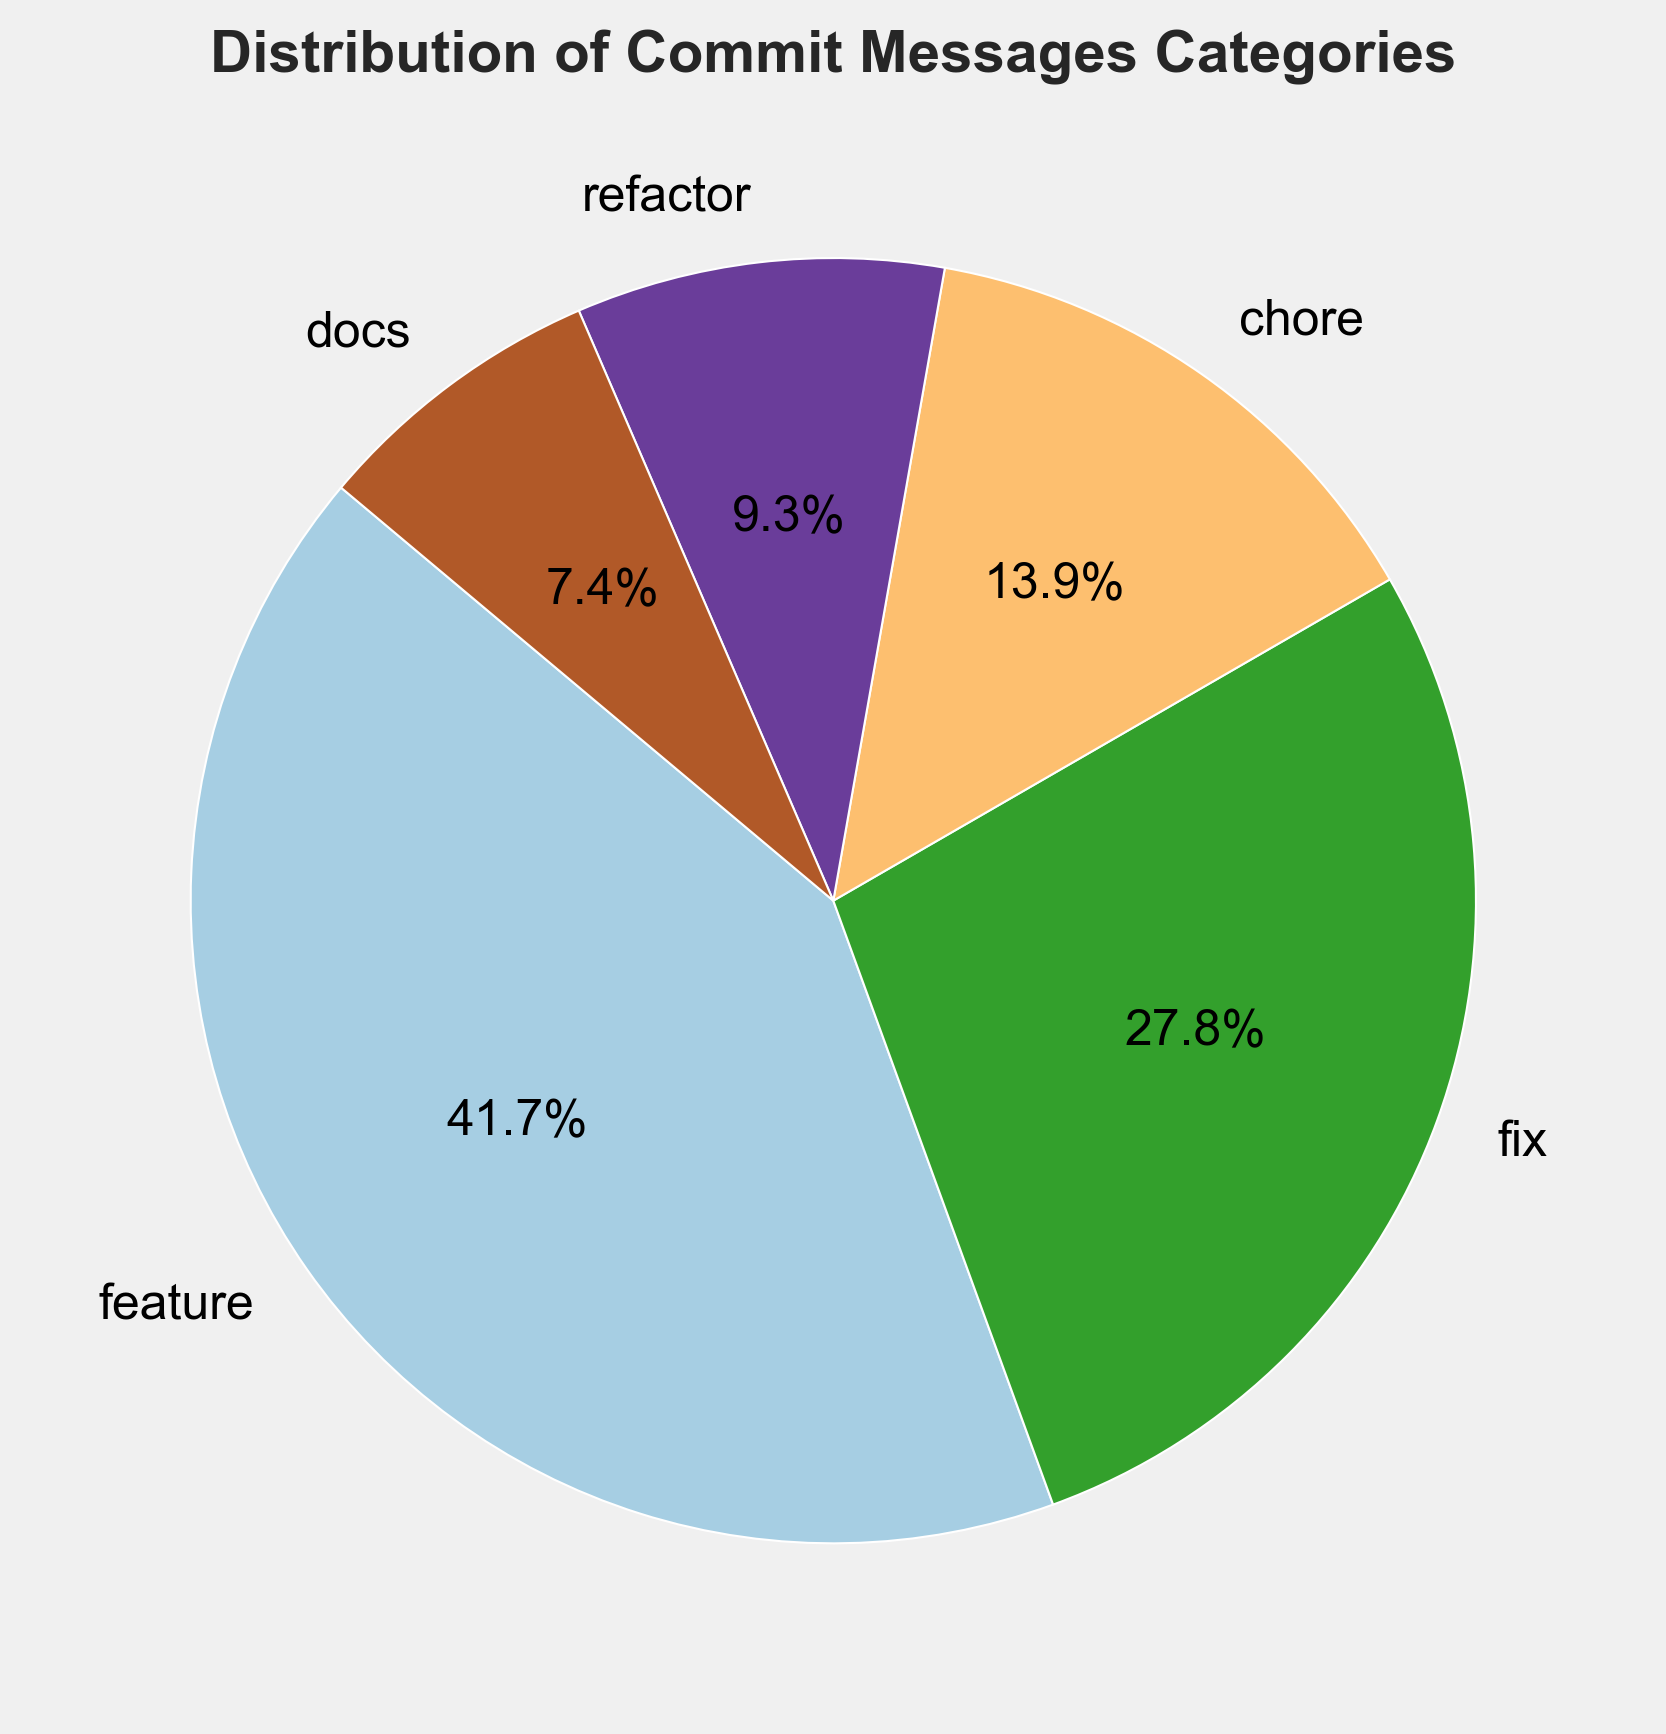Which category has the highest count of commits? The category "feature" has the largest wedge in the pie chart, indicating it has the highest count of commits.
Answer: feature Which category has the smallest percentage of commits? The category "docs" has the smallest wedge in the pie chart, indicating it has the smallest percentage.
Answer: docs What is the percentage of commits that are "fixes"? Referring to the pie chart, the "fix" category represents 30 commits out of a total of 108. The percentage is calculated as (30/108) * 100 = 27.8%.
Answer: 27.8% How many categories have more than 20% of total commits? The wedges corresponding to "feature" and "fix" categories are both more significant than 20%, indicating there are 2 categories over 20%.
Answer: 2 Is the "chore" category count greater than the "refactor" category count? By comparing the sizes of the wedges, the "chore" category is larger than the "refactor" category. Hence, "chore" has a greater count than "refactor".
Answer: Yes Which categories combined make up less than 15% of the total commits? The "docs" category alone represents 7.4%, and combined "refactor" and "docs" make up 16.7%, over 15%. Hence, only the "docs" category is less than 15%.
Answer: docs If you combine the "chore" and "refactor" categories, what percentage of total commits do they represent? The counts for "chore" and "refactor" are 15 and 10, respectively. Combined, they have 25 commits. The total commits are 108. The percentage is (25/108) * 100 = 23.1%.
Answer: 23.1% Are "feature" and "fix" categories together more than half of the total commits? The counts for "feature" and "fix" are 45 and 30, respectively. Combined, they have 75 commits out of 108. The percentage is (75/108) * 100 = 69.4%, which is more than half.
Answer: Yes Is the number of "docs" commits closer to the number of "refactor" or "chore" commits? The "docs" category has 8 commits, "refactor" has 10, and "chore" has 15. The difference between "docs" and "refactor" is 2 and with "chore" is 7. Hence, it's closer to "refactor".
Answer: refactor 